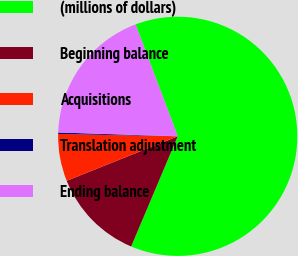Convert chart to OTSL. <chart><loc_0><loc_0><loc_500><loc_500><pie_chart><fcel>(millions of dollars)<fcel>Beginning balance<fcel>Acquisitions<fcel>Translation adjustment<fcel>Ending balance<nl><fcel>62.09%<fcel>12.57%<fcel>6.38%<fcel>0.19%<fcel>18.76%<nl></chart> 